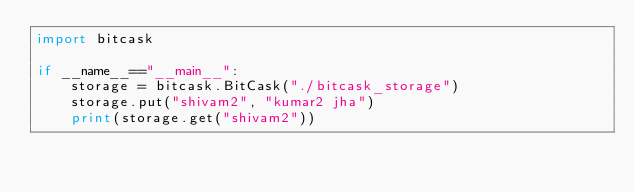Convert code to text. <code><loc_0><loc_0><loc_500><loc_500><_Python_>import bitcask

if __name__=="__main__":
    storage = bitcask.BitCask("./bitcask_storage")
    storage.put("shivam2", "kumar2 jha")
    print(storage.get("shivam2"))</code> 